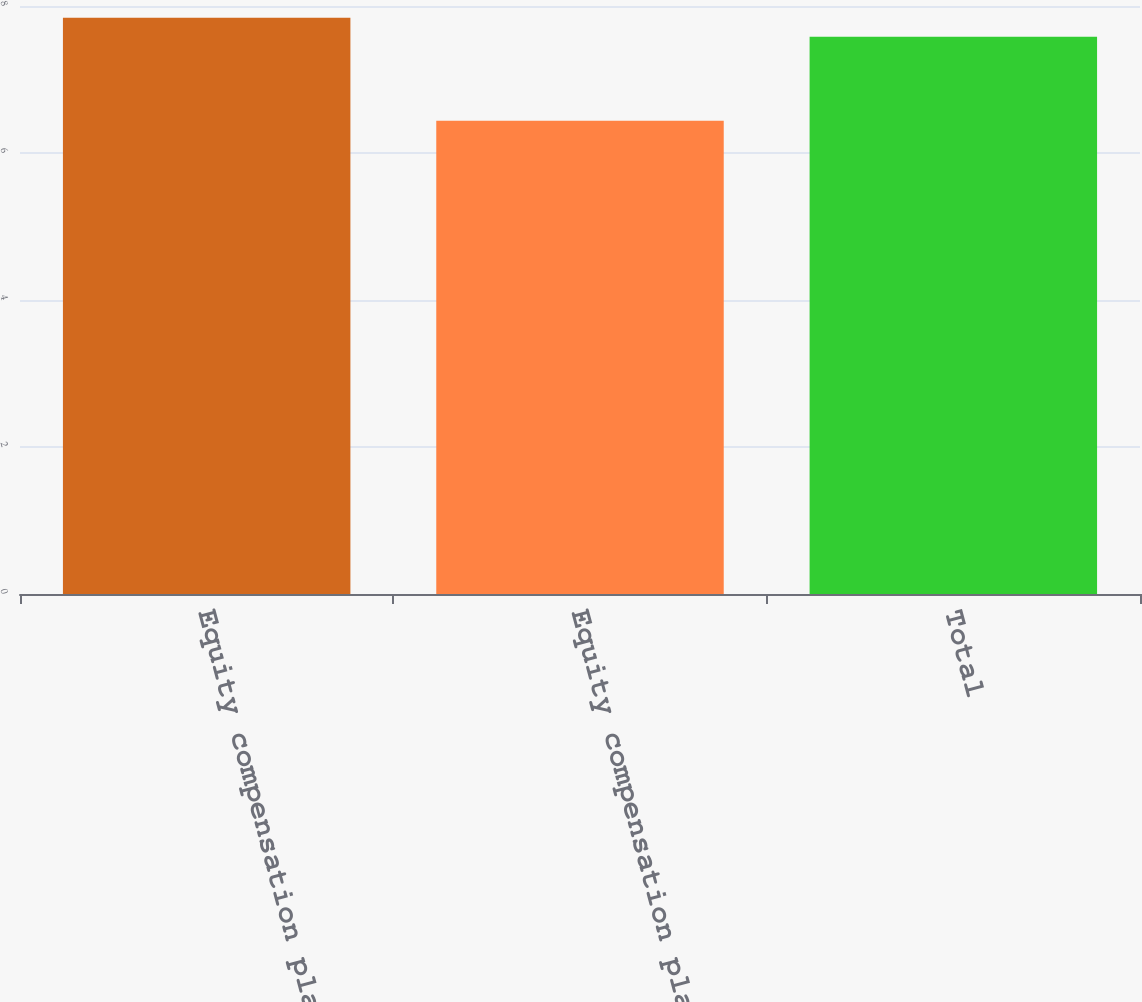Convert chart. <chart><loc_0><loc_0><loc_500><loc_500><bar_chart><fcel>Equity compensation plans<fcel>Equity compensation plans not<fcel>Total<nl><fcel>7.84<fcel>6.44<fcel>7.58<nl></chart> 